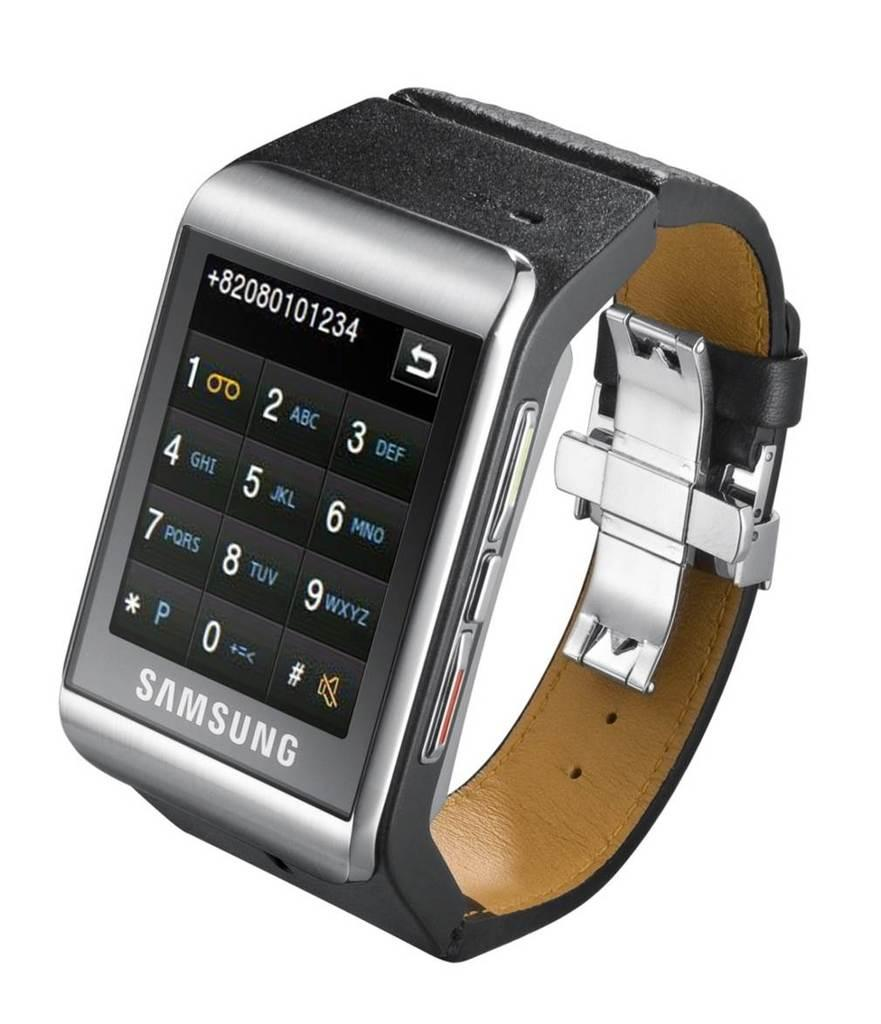<image>
Relay a brief, clear account of the picture shown. Samsung smart watch with the numbers 82080101234 near the top. 